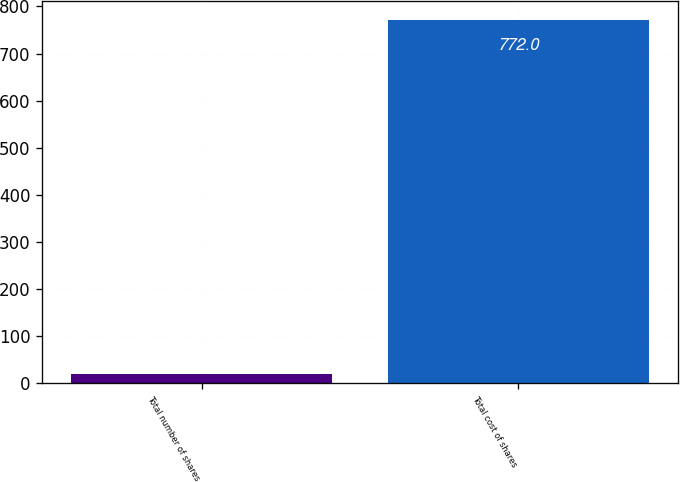<chart> <loc_0><loc_0><loc_500><loc_500><bar_chart><fcel>Total number of shares<fcel>Total cost of shares<nl><fcel>18.3<fcel>772<nl></chart> 